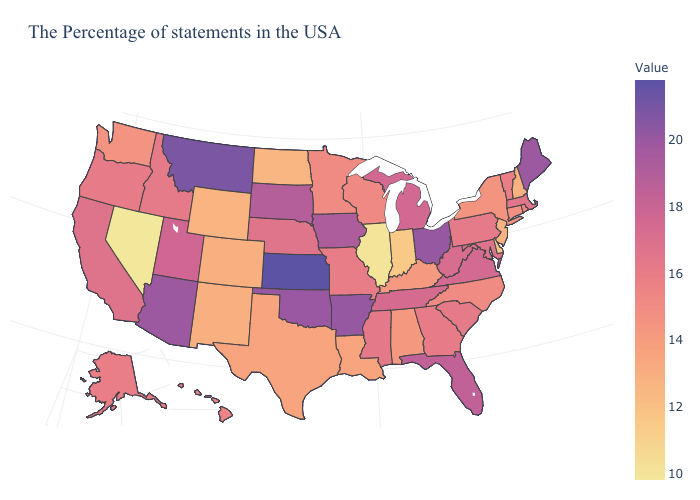Among the states that border New York , does New Jersey have the lowest value?
Write a very short answer. Yes. Which states have the highest value in the USA?
Be succinct. Kansas. Does Michigan have a lower value than Georgia?
Be succinct. No. Among the states that border South Dakota , does Wyoming have the highest value?
Write a very short answer. No. 